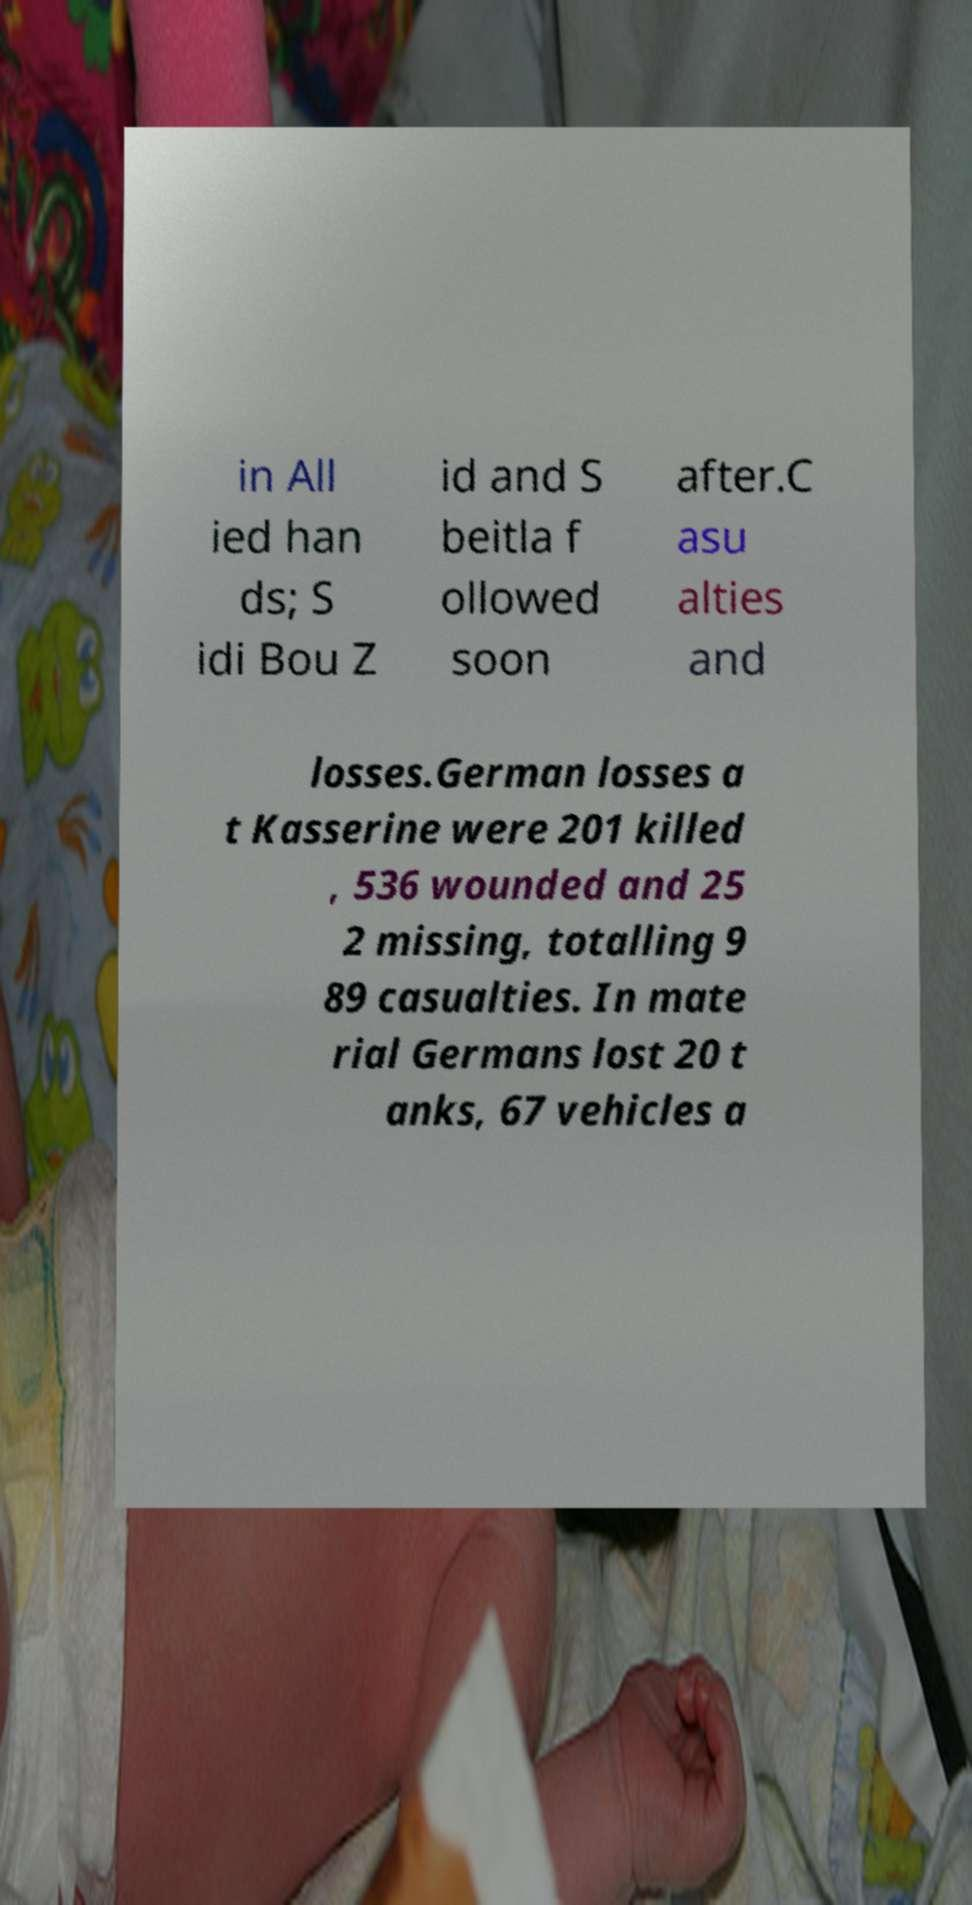What messages or text are displayed in this image? I need them in a readable, typed format. in All ied han ds; S idi Bou Z id and S beitla f ollowed soon after.C asu alties and losses.German losses a t Kasserine were 201 killed , 536 wounded and 25 2 missing, totalling 9 89 casualties. In mate rial Germans lost 20 t anks, 67 vehicles a 